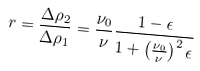<formula> <loc_0><loc_0><loc_500><loc_500>r = \frac { \Delta \rho _ { 2 } } { \Delta \rho _ { 1 } } = \frac { \nu _ { 0 } } { \nu } \frac { 1 - \epsilon } { 1 + \left ( \frac { \nu _ { 0 } } { \nu } \right ) ^ { 2 } \epsilon }</formula> 